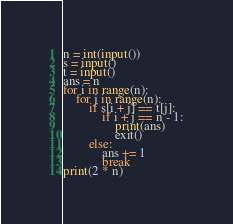Convert code to text. <code><loc_0><loc_0><loc_500><loc_500><_Python_>n = int(input())
s = input()
t = input()
ans = n
for i in range(n):
    for j in range(n):
        if s[i + j] == t[j]:
            if i + j == n - 1:
                print(ans)
                exit()
        else:
            ans += 1
            break
print(2 * n)</code> 